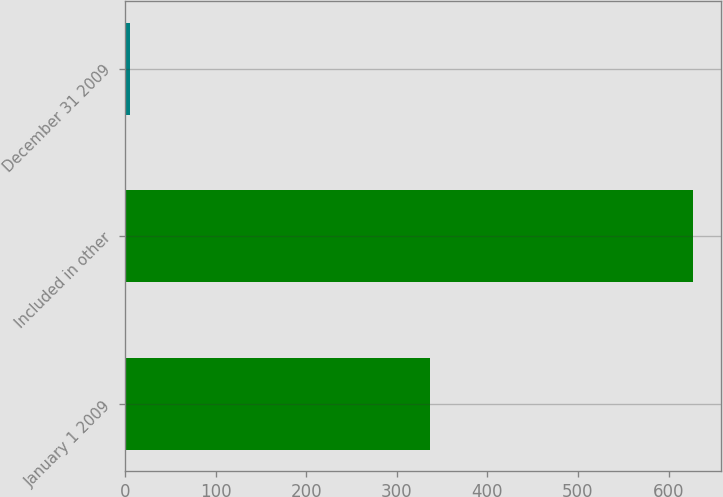<chart> <loc_0><loc_0><loc_500><loc_500><bar_chart><fcel>January 1 2009<fcel>Included in other<fcel>December 31 2009<nl><fcel>337<fcel>627<fcel>6<nl></chart> 